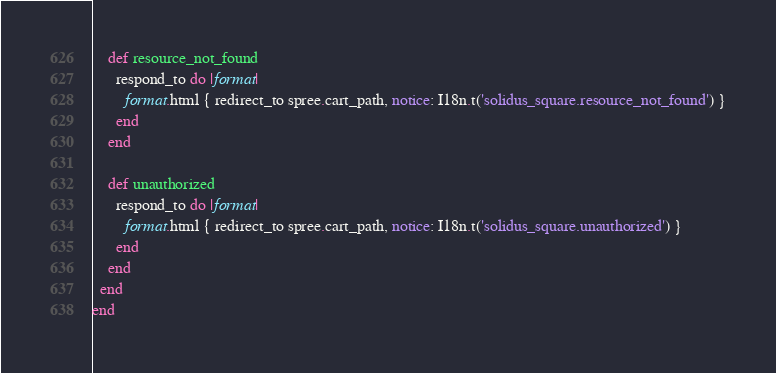Convert code to text. <code><loc_0><loc_0><loc_500><loc_500><_Ruby_>    def resource_not_found
      respond_to do |format|
        format.html { redirect_to spree.cart_path, notice: I18n.t('solidus_square.resource_not_found') }
      end
    end

    def unauthorized
      respond_to do |format|
        format.html { redirect_to spree.cart_path, notice: I18n.t('solidus_square.unauthorized') }
      end
    end
  end
end
</code> 